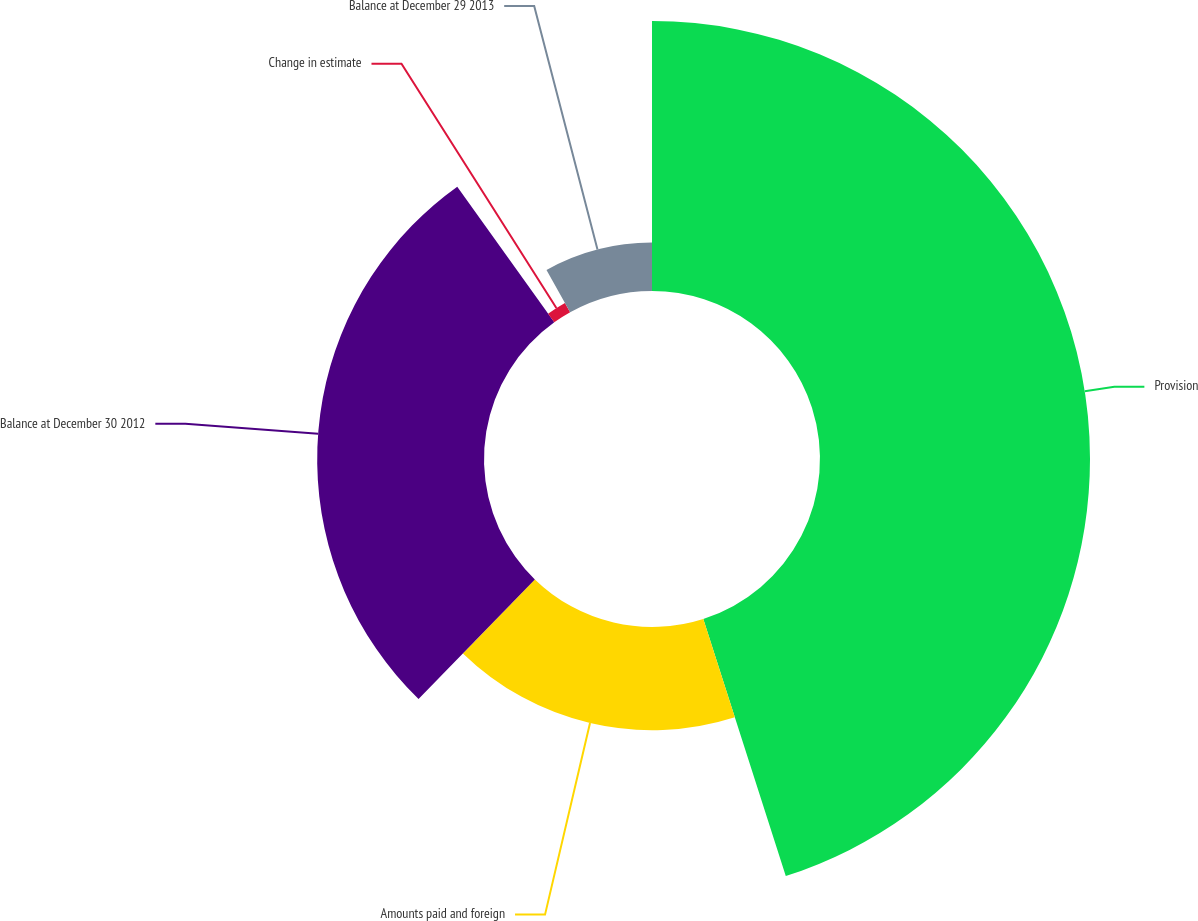<chart> <loc_0><loc_0><loc_500><loc_500><pie_chart><fcel>Provision<fcel>Amounts paid and foreign<fcel>Balance at December 30 2012<fcel>Change in estimate<fcel>Balance at December 29 2013<nl><fcel>45.06%<fcel>17.22%<fcel>27.84%<fcel>1.78%<fcel>8.1%<nl></chart> 